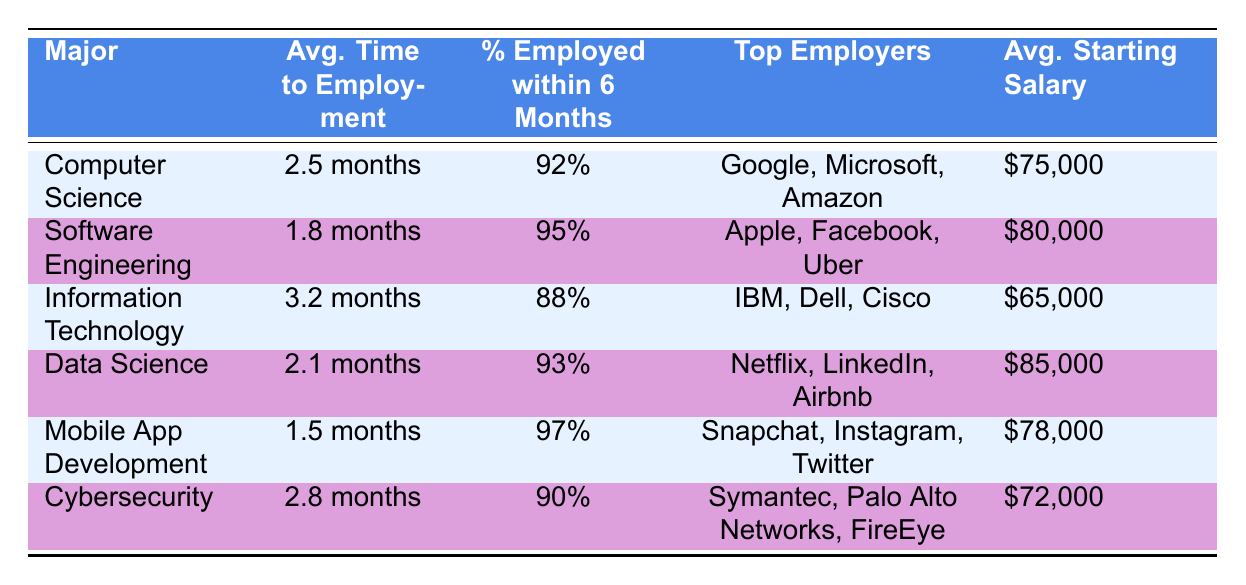What is the average time to employment for Mobile App Development? The table shows that the average time to employment for Mobile App Development is 1.5 months.
Answer: 1.5 months Which major has the highest percentage of graduates employed within 6 months? By comparing the percentages in the table, Mobile App Development at 97% has the highest percentage of graduates employed within 6 months.
Answer: Mobile App Development What is the average starting salary for Data Science graduates? The table indicates that the average starting salary for Data Science graduates is $85,000.
Answer: $85,000 Is the average time to employment for Cybersecurity greater than 2 months? The average time to employment for Cybersecurity is 2.8 months, which is greater than 2 months.
Answer: Yes What is the average starting salary of graduates in Software Engineering compared to Cybersecurity? The average starting salary for Software Engineering is $80,000 and for Cybersecurity is $72,000. Thus, the difference is $80,000 - $72,000 = $8,000, making Software Engineering higher by that amount.
Answer: $8,000 Which majors have an average time to employment less than 2 months? Looking through the table, only Mobile App Development with 1.5 months and Software Engineering with 1.8 months have an average time to employment less than 2 months.
Answer: Mobile App Development and Software Engineering What is the average time to employment for all listed majors? To find the average, sum the times: 2.5 + 1.8 + 3.2 + 2.1 + 1.5 + 2.8 = 13.0 months. There are 6 majors, so the average time is 13.0 / 6 = 2.17 months.
Answer: 2.17 months Are graduates from Information Technology less likely to be employed within 6 months compared to those from Cybersecurity? Yes, the Data shows that 88% of Information Technology graduates are employed within 6 months, while 90% of Cybersecurity graduates are employed in that time.
Answer: No What are the top employers for graduates of Mobile App Development? The table lists Snapchat, Instagram, and Twitter as the top employers for Mobile App Development graduates.
Answer: Snapchat, Instagram, Twitter 